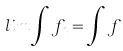Convert formula to latex. <formula><loc_0><loc_0><loc_500><loc_500>l i m \int f _ { n } = \int f</formula> 